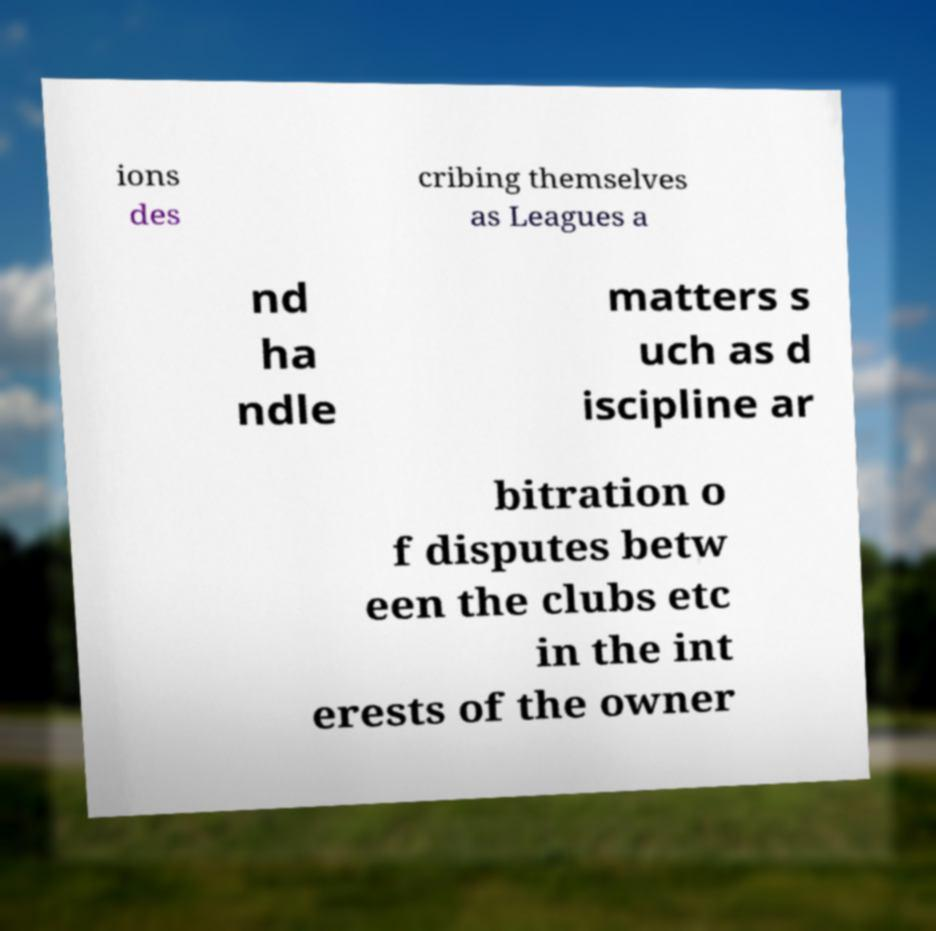What messages or text are displayed in this image? I need them in a readable, typed format. ions des cribing themselves as Leagues a nd ha ndle matters s uch as d iscipline ar bitration o f disputes betw een the clubs etc in the int erests of the owner 